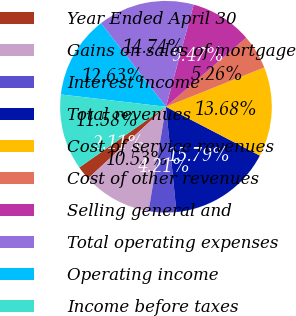<chart> <loc_0><loc_0><loc_500><loc_500><pie_chart><fcel>Year Ended April 30<fcel>Gains on sales of mortgage<fcel>Interest income<fcel>Total revenues<fcel>Cost of service revenues<fcel>Cost of other revenues<fcel>Selling general and<fcel>Total operating expenses<fcel>Operating income<fcel>Income before taxes<nl><fcel>2.11%<fcel>10.53%<fcel>4.21%<fcel>15.79%<fcel>13.68%<fcel>5.26%<fcel>9.47%<fcel>14.74%<fcel>12.63%<fcel>11.58%<nl></chart> 